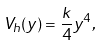Convert formula to latex. <formula><loc_0><loc_0><loc_500><loc_500>V _ { h } ( y ) = \frac { k } { 4 } y ^ { 4 } ,</formula> 